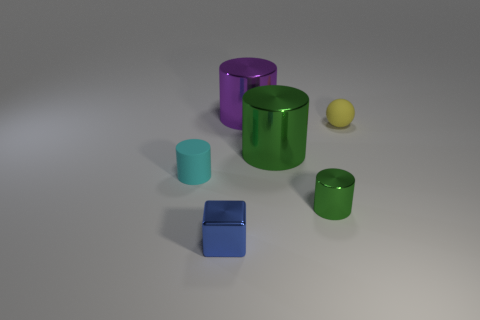What might be the purpose of these objects? The objects in the image could serve decorative purposes due to their colorful and polished appearance. Alternatively, they might be part of a children's learning toy set designed to teach about shapes, sizes, and colors through hands-on interaction. 